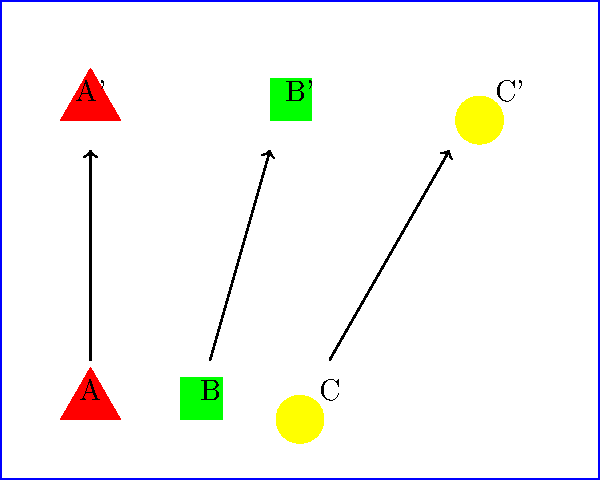A child's lunchbox is represented by the blue rectangle. Three food items (A, B, and C) need to be rearranged to create a more visually appealing layout (A', B', and C'). Determine the translation vector for shape B (the square) to move it from its original position to its new position. To find the translation vector for shape B, we need to follow these steps:

1. Identify the initial and final positions of shape B:
   - Initial position (center of B): (3.5, 1.5)
   - Final position (center of B'): (5, 6.5)

2. Calculate the horizontal displacement:
   $x_{displacement} = 5 - 3.5 = 1.5$ units to the right

3. Calculate the vertical displacement:
   $y_{displacement} = 6.5 - 1.5 = 5$ units upward

4. Combine the horizontal and vertical displacements to form the translation vector:
   Translation vector = $\langle 1.5, 5 \rangle$

This vector represents the movement of shape B from its original position to its new position in the lunchbox layout.
Answer: $\langle 1.5, 5 \rangle$ 